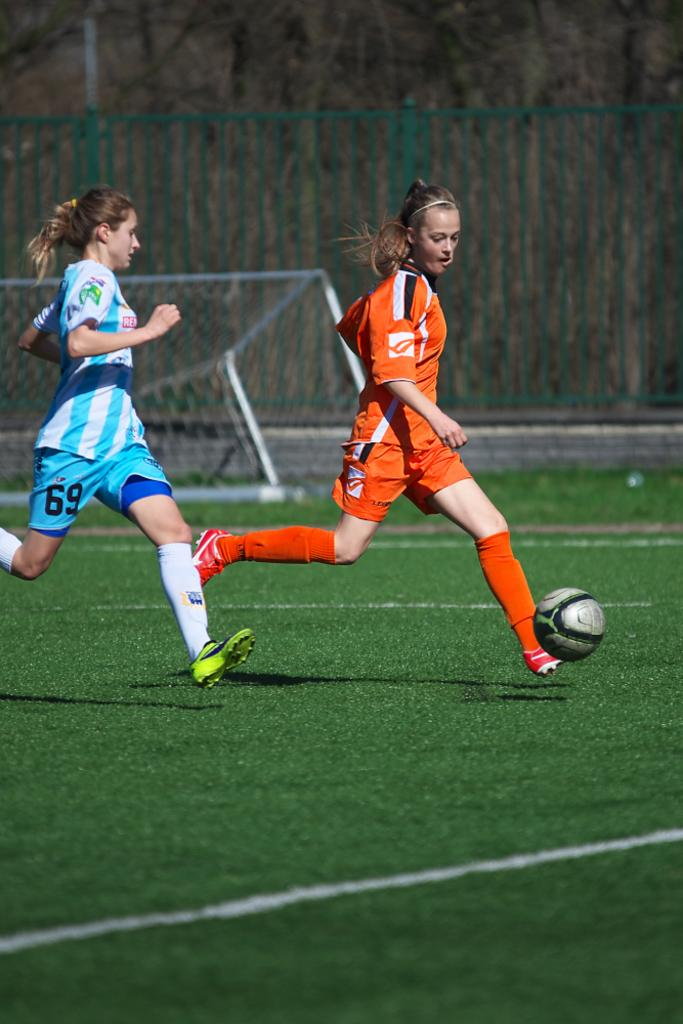<image>
Create a compact narrative representing the image presented. Soccer player with a turquoise and white uniform with the 69 on the right leg of the shorts. 